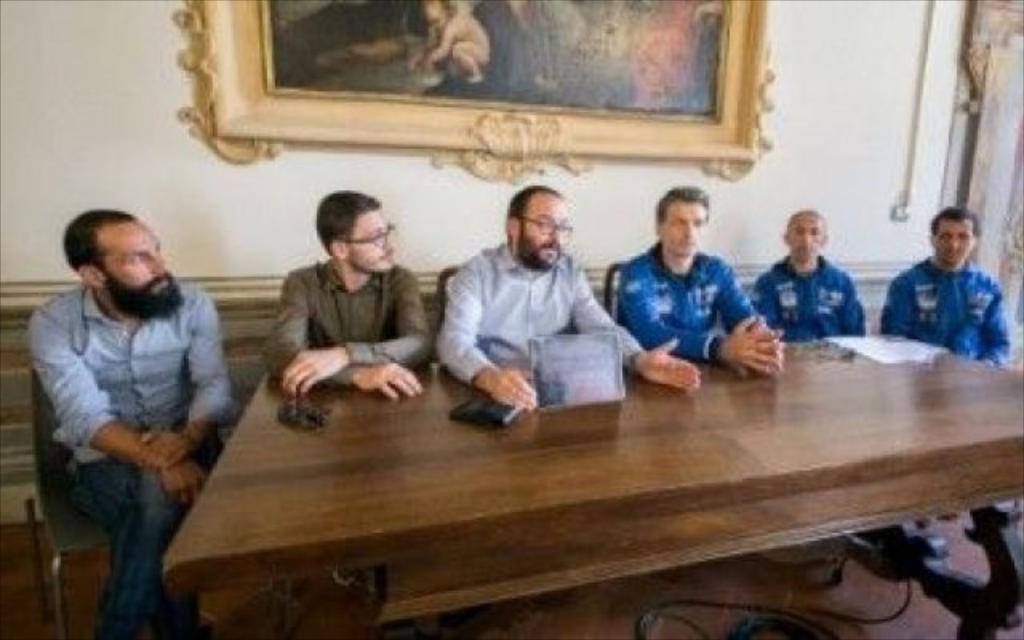Could you give a brief overview of what you see in this image? In this image we can see this people are sitting in front of the table. In the background we can see a photo frame on the wall. 